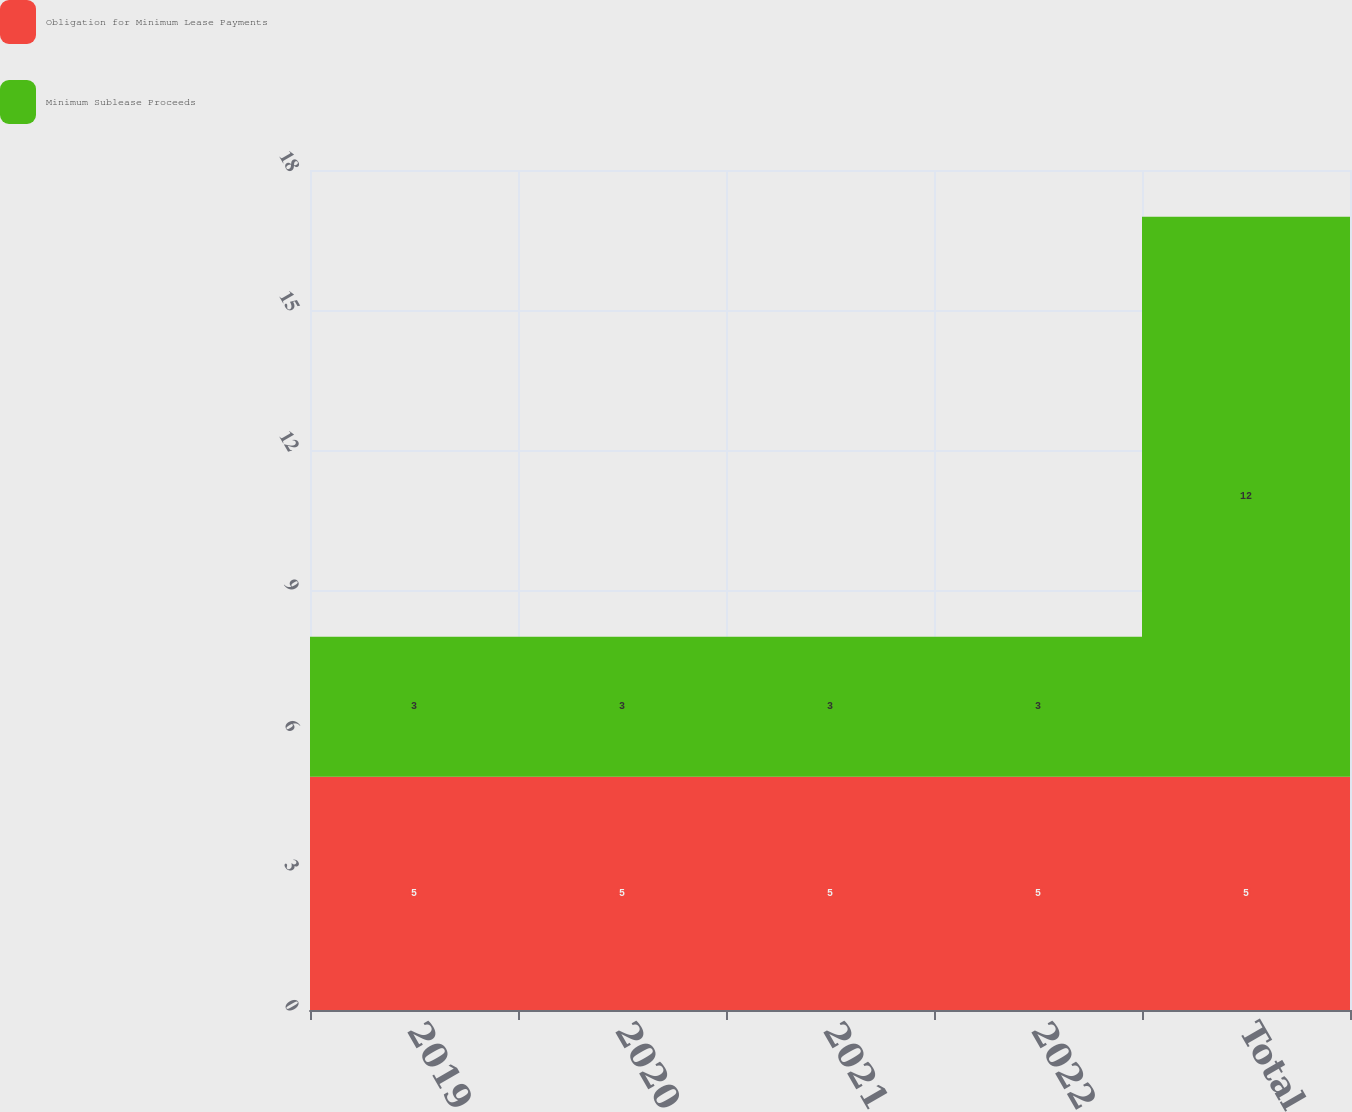Convert chart. <chart><loc_0><loc_0><loc_500><loc_500><stacked_bar_chart><ecel><fcel>2019<fcel>2020<fcel>2021<fcel>2022<fcel>Total<nl><fcel>Obligation for Minimum Lease Payments<fcel>5<fcel>5<fcel>5<fcel>5<fcel>5<nl><fcel>Minimum Sublease Proceeds<fcel>3<fcel>3<fcel>3<fcel>3<fcel>12<nl></chart> 